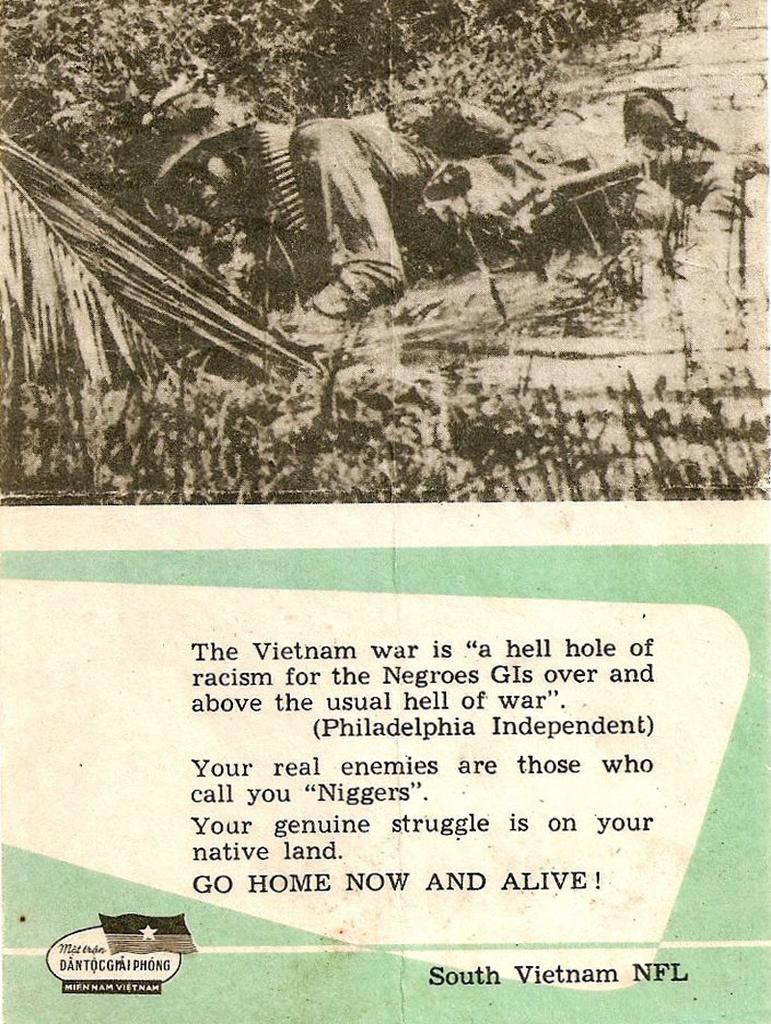Can you describe this image briefly? This is a poster. At the top of the image there is a person lying. There are trees. At the bottom of the image there is text. 